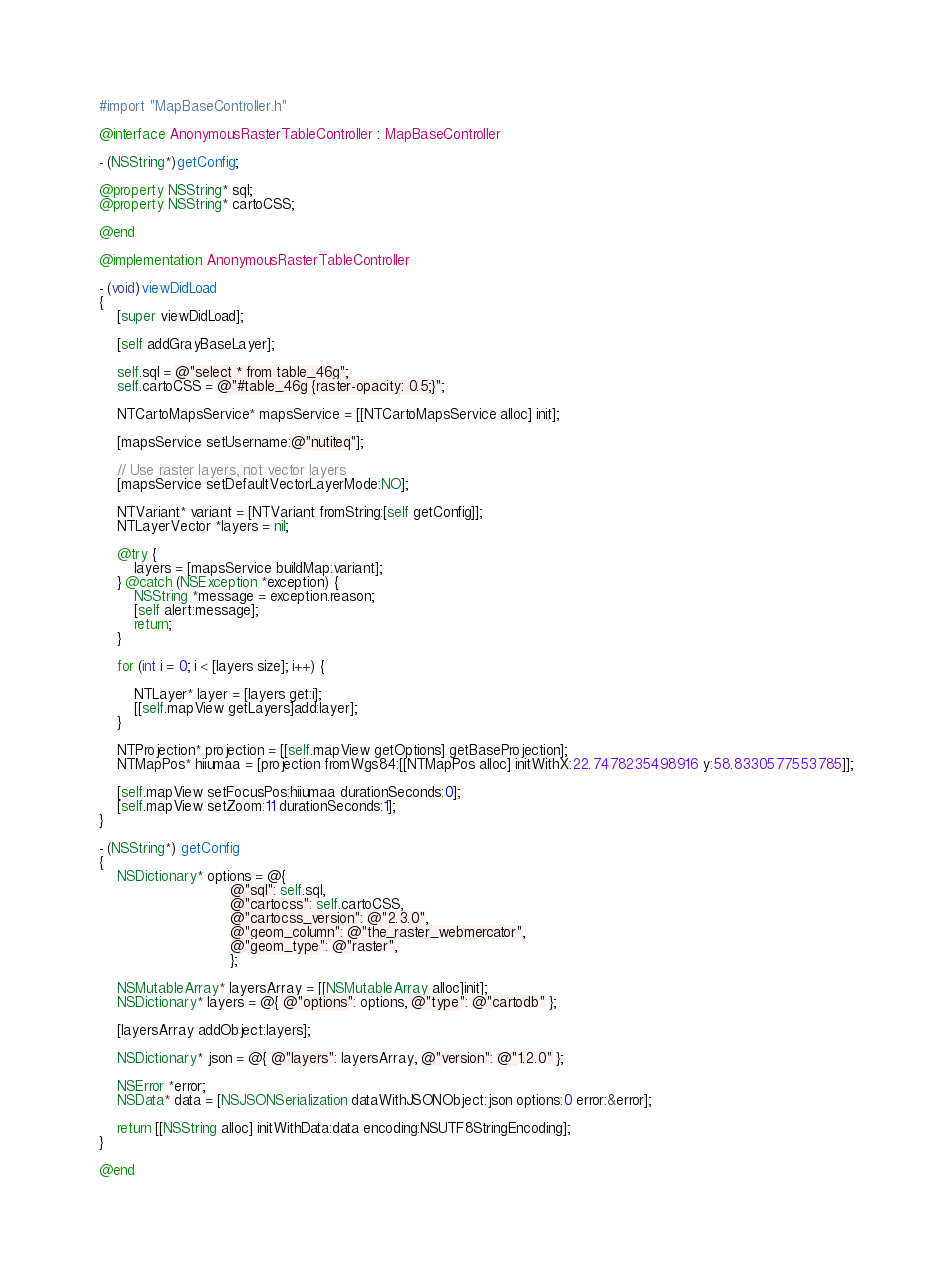Convert code to text. <code><loc_0><loc_0><loc_500><loc_500><_ObjectiveC_>
#import "MapBaseController.h"

@interface AnonymousRasterTableController : MapBaseController

- (NSString*)getConfig;

@property NSString* sql;
@property NSString* cartoCSS;

@end

@implementation AnonymousRasterTableController

- (void)viewDidLoad
{
    [super viewDidLoad];
    
    [self addGrayBaseLayer];
    
    self.sql = @"select * from table_46g";
    self.cartoCSS = @"#table_46g {raster-opacity: 0.5;}";
    
    NTCartoMapsService* mapsService = [[NTCartoMapsService alloc] init];
    
    [mapsService setUsername:@"nutiteq"];
    
    // Use raster layers, not vector layers
    [mapsService setDefaultVectorLayerMode:NO];
    
    NTVariant* variant = [NTVariant fromString:[self getConfig]];
    NTLayerVector *layers = nil;
    
    @try {
        layers = [mapsService buildMap:variant];
    } @catch (NSException *exception) {
        NSString *message = exception.reason;
        [self alert:message];
        return;
    }
    
    for (int i = 0; i < [layers size]; i++) {
        
        NTLayer* layer = [layers get:i];
        [[self.mapView getLayers]add:layer];
    }
    
    NTProjection* projection = [[self.mapView getOptions] getBaseProjection];
    NTMapPos* hiiumaa = [projection fromWgs84:[[NTMapPos alloc] initWithX:22.7478235498916 y:58.8330577553785]];
    
    [self.mapView setFocusPos:hiiumaa durationSeconds:0];
    [self.mapView setZoom:11 durationSeconds:1];
}

- (NSString*) getConfig
{
    NSDictionary* options = @{
                              @"sql": self.sql,
                              @"cartocss": self.cartoCSS,
                              @"cartocss_version": @"2.3.0",
                              @"geom_column": @"the_raster_webmercator",
                              @"geom_type": @"raster",
                              };
    
    NSMutableArray* layersArray = [[NSMutableArray alloc]init];
    NSDictionary* layers = @{ @"options": options, @"type": @"cartodb" };

    [layersArray addObject:layers];
    
    NSDictionary* json = @{ @"layers": layersArray, @"version": @"1.2.0" };
    
    NSError *error;
    NSData* data = [NSJSONSerialization dataWithJSONObject:json options:0 error:&error];
    
    return [[NSString alloc] initWithData:data encoding:NSUTF8StringEncoding];
}

@end







</code> 